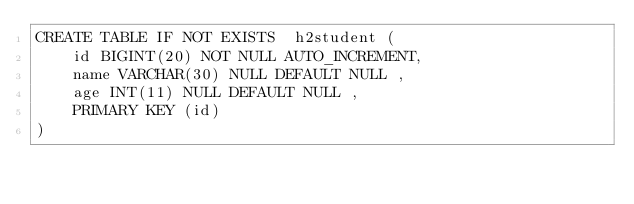<code> <loc_0><loc_0><loc_500><loc_500><_SQL_>CREATE TABLE IF NOT EXISTS  h2student (
	id BIGINT(20) NOT NULL AUTO_INCREMENT,
	name VARCHAR(30) NULL DEFAULT NULL ,
	age INT(11) NULL DEFAULT NULL ,
	PRIMARY KEY (id)
)

</code> 